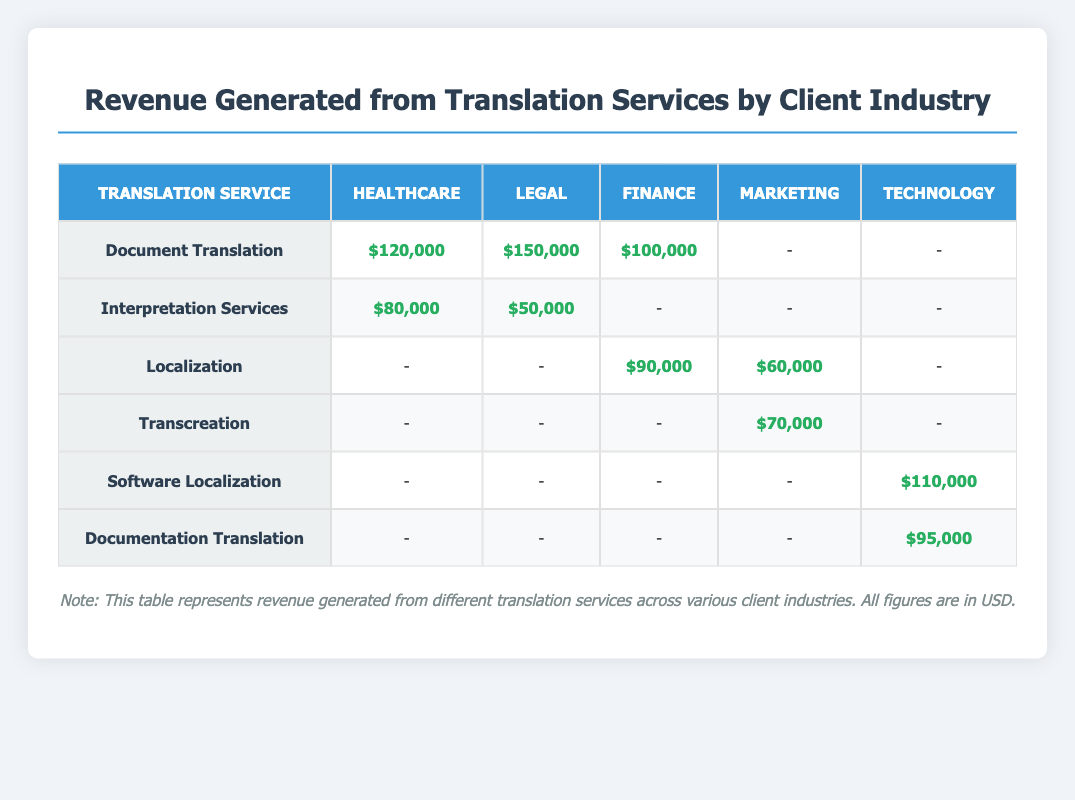What is the highest revenue generated from a single translation service in the healthcare industry? The highest revenue in the healthcare industry is from Document Translation, which generated $120,000.
Answer: $120,000 Which client industry has the lowest total revenue from the translation services listed? For each industry, summing the revenues gives: Healthcare ($200,000), Legal ($200,000), Finance ($190,000), Marketing ($130,000), Technology ($205,000). The lowest total revenue is from the Marketing industry, which is $130,000.
Answer: Marketing Is there any revenue generated from Transcreation in the healthcare industry? According to the table, there is no revenue listed for Transcreation in the healthcare industry.
Answer: No What is the total revenue generated from all translation services for the Legal industry? For the Legal industry, adding revenue from Document Translation ($150,000) and Interpretation Services ($50,000) gives $150,000 + $50,000 = $200,000.
Answer: $200,000 Does the localization service generate more revenue than interpretation services in the finance industry? Localization in the finance industry generated $90,000, while interpretation services generated no revenue. Since $90,000 is greater than $0, localization generates more revenue.
Answer: Yes Which translation service is generating the most revenue across all industries? By evaluating all services: Document Translation ($370,000), Interpretation Services ($130,000), Localization ($150,000), Transcreation ($70,000), Software Localization ($110,000), and Documentation Translation ($95,000), Document Translation generates the most revenue.
Answer: Document Translation What would be the total revenue if we only consider the technology industry's contributions? In the technology industry, adding revenue from Software Localization ($110,000) and Documentation Translation ($95,000) results in a total of $110,000 + $95,000 = $205,000.
Answer: $205,000 Is there any client industry that has no entries for Document Translation? Looking through the table, both the Marketing and Technology industries do not have any entries for Document Translation, hence there are industries without entries for this service.
Answer: Yes What is the average revenue generated from the localization service across the industries that have it? The localization service generated revenues of $90,000 (Finance) and $60,000 (Marketing). Adding these, we get $90,000 + $60,000 = $150,000. Dividing by the number of industries (2) gives $150,000 / 2 = $75,000.
Answer: $75,000 